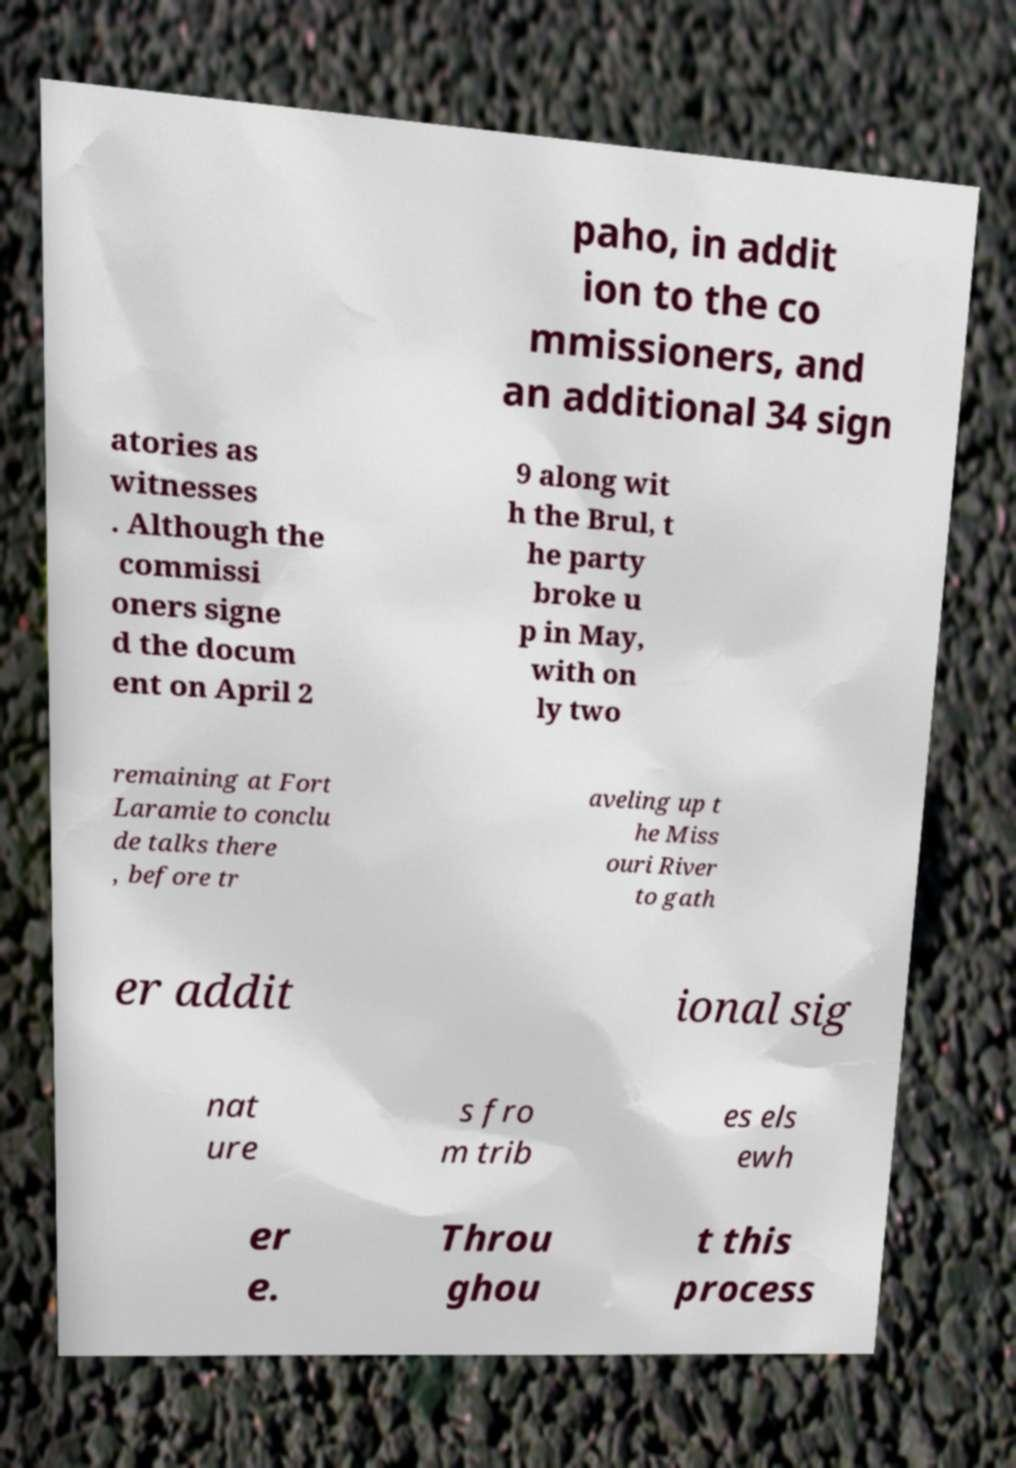Can you read and provide the text displayed in the image?This photo seems to have some interesting text. Can you extract and type it out for me? paho, in addit ion to the co mmissioners, and an additional 34 sign atories as witnesses . Although the commissi oners signe d the docum ent on April 2 9 along wit h the Brul, t he party broke u p in May, with on ly two remaining at Fort Laramie to conclu de talks there , before tr aveling up t he Miss ouri River to gath er addit ional sig nat ure s fro m trib es els ewh er e. Throu ghou t this process 